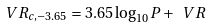<formula> <loc_0><loc_0><loc_500><loc_500>\ V R _ { c , - 3 . 6 5 } = 3 . 6 5 \log _ { 1 0 } P + \ V R</formula> 